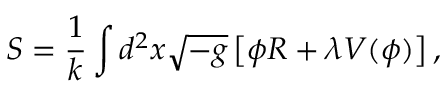Convert formula to latex. <formula><loc_0><loc_0><loc_500><loc_500>S = \frac { 1 } { k } \int d ^ { 2 } x \sqrt { - g } \left [ \phi R + \lambda V ( \phi ) \right ] ,</formula> 